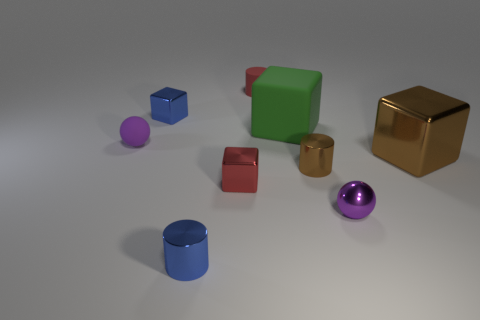There is a red metal thing that is the same size as the brown metal cylinder; what is its shape?
Your answer should be compact. Cube. Is the number of tiny shiny cylinders left of the tiny matte cylinder the same as the number of tiny brown cylinders on the left side of the brown shiny block?
Your answer should be compact. Yes. Does the purple object that is right of the red rubber thing have the same material as the big brown block?
Provide a succinct answer. Yes. What color is the shiny object that is to the left of the red metal thing and in front of the red metallic block?
Ensure brevity in your answer.  Blue. There is a small sphere to the right of the tiny rubber ball; what number of green things are in front of it?
Keep it short and to the point. 0. What material is the other big brown object that is the same shape as the big rubber object?
Your answer should be very brief. Metal. What is the color of the large matte block?
Your response must be concise. Green. What number of things are either big brown cubes or tiny blue objects?
Ensure brevity in your answer.  3. There is a tiny blue metal object that is to the right of the cube behind the big green object; what is its shape?
Keep it short and to the point. Cylinder. What number of other objects are there of the same material as the green block?
Provide a short and direct response. 2. 